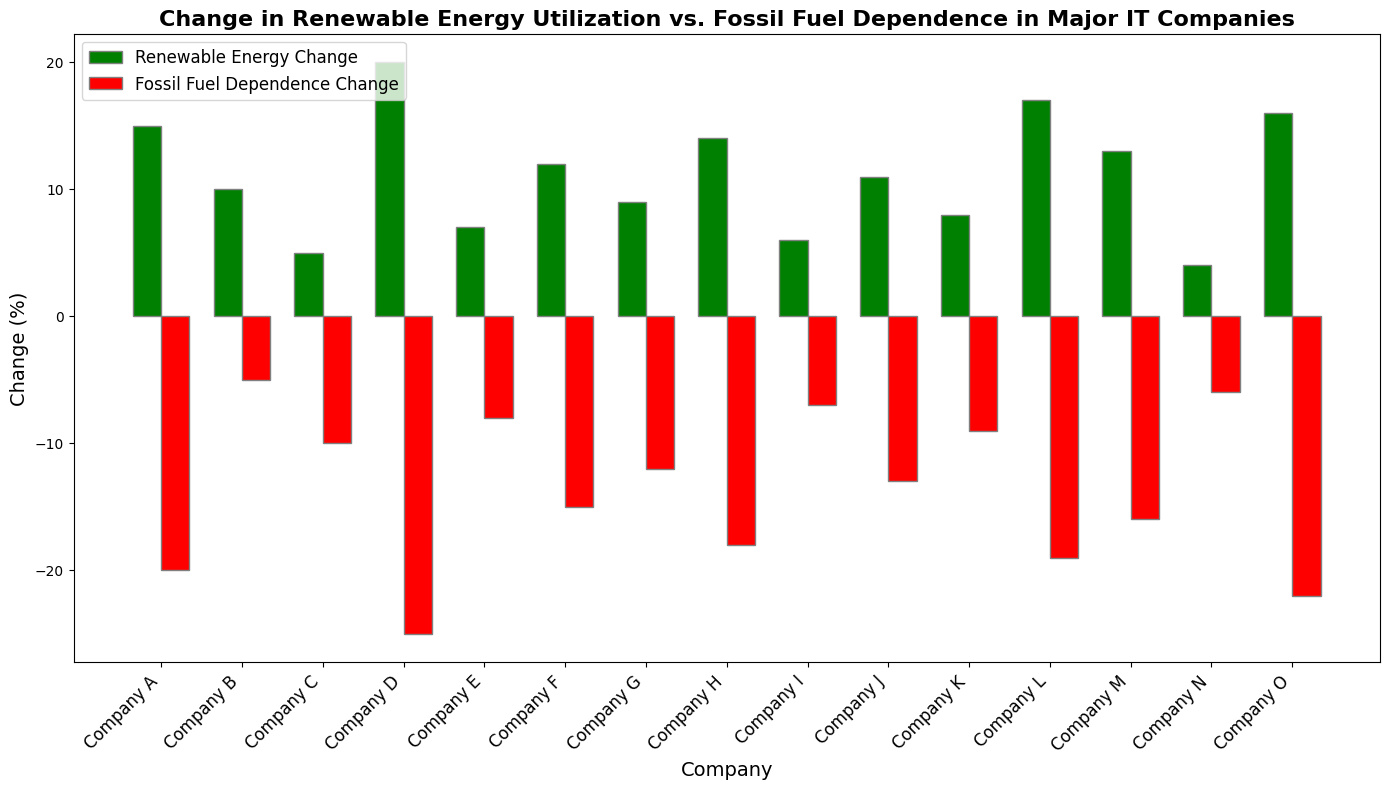Which company has the largest increase in renewable energy utilization? From the figure, we can see the green bar that represents the renewable energy change is the tallest for Company D.
Answer: Company D Which company has the largest decrease in fossil fuel dependence? From the figure, we can see the red bar that represents the fossil fuel dependence change is the lowest for Company O.
Answer: Company O Which two companies have the smallest difference between their renewable energy change and fossil fuel dependence change? By comparing the heights of the green and red bars for each company, Companies I and M have closely matched heights, indicating a small difference.
Answer: Companies I and M How much more did Company L increase its renewable energy utilization compared to Company K? The height of the green bar for Company L is 17 and for Company K is 8. The difference is 17 - 8 = 9.
Answer: 9% Which companies have their renewable energy change above 10% and fossil fuel dependence change below -15%? From the figure, visually identify the companies where the green bar is above the 10% mark and the red bar is below -15%. These companies are D, H, and M.
Answer: Companies D, H, and M What is the sum of the renewable energy change for companies that have more than 10% increase in renewable energy utilization? Sum the heights of the green bars for companies with more than 10% renewable energy change: 15 (A) + 20 (D) + 12 (F) + 14 (H) + 17 (L) + 13 (M) + 16 (O) = 107.
Answer: 107% Which company has an equal increase in renewable energy utilization to Company C's decrease in fossil fuel dependence? From the figure, the green bar for Company B shows a 10% increase, which is equal to the height of the red bar for Company C with a 10% decrease.
Answer: Company B What is the average change in fossil fuel dependence for all companies? Add up all the changes in fossil fuel dependence and divide by the number of companies: (-20) + (-5) + (-10) + (-25) + (-8) + (-15) + (-12) + (-18) + (-7) + (-13) + (-9) + (-19) + (-16) + (-6) + (-22) = -185. The average is -185/15 = -12.33.
Answer: -12.33% Which company has an equal renewable energy change to its fossil fuel dependence change, but in the opposite direction? Visually inspect the bars for each company. Company G has a green bar of height 9% and a red bar of height -12%, which are not equal but close. No company has exactly equal but opposite values.
Answer: None 